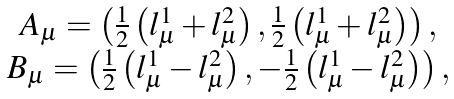Convert formula to latex. <formula><loc_0><loc_0><loc_500><loc_500>\begin{array} { c } A _ { \mu } = \left ( \frac { 1 } { 2 } \left ( l _ { \mu } ^ { 1 } + l _ { \mu } ^ { 2 } \right ) , \frac { 1 } { 2 } \left ( l _ { \mu } ^ { 1 } + l _ { \mu } ^ { 2 } \right ) \right ) , \\ B _ { \mu } = \left ( \frac { 1 } { 2 } \left ( l _ { \mu } ^ { 1 } - l _ { \mu } ^ { 2 } \right ) , - \frac { 1 } { 2 } \left ( l _ { \mu } ^ { 1 } - l _ { \mu } ^ { 2 } \right ) \right ) , \end{array}</formula> 